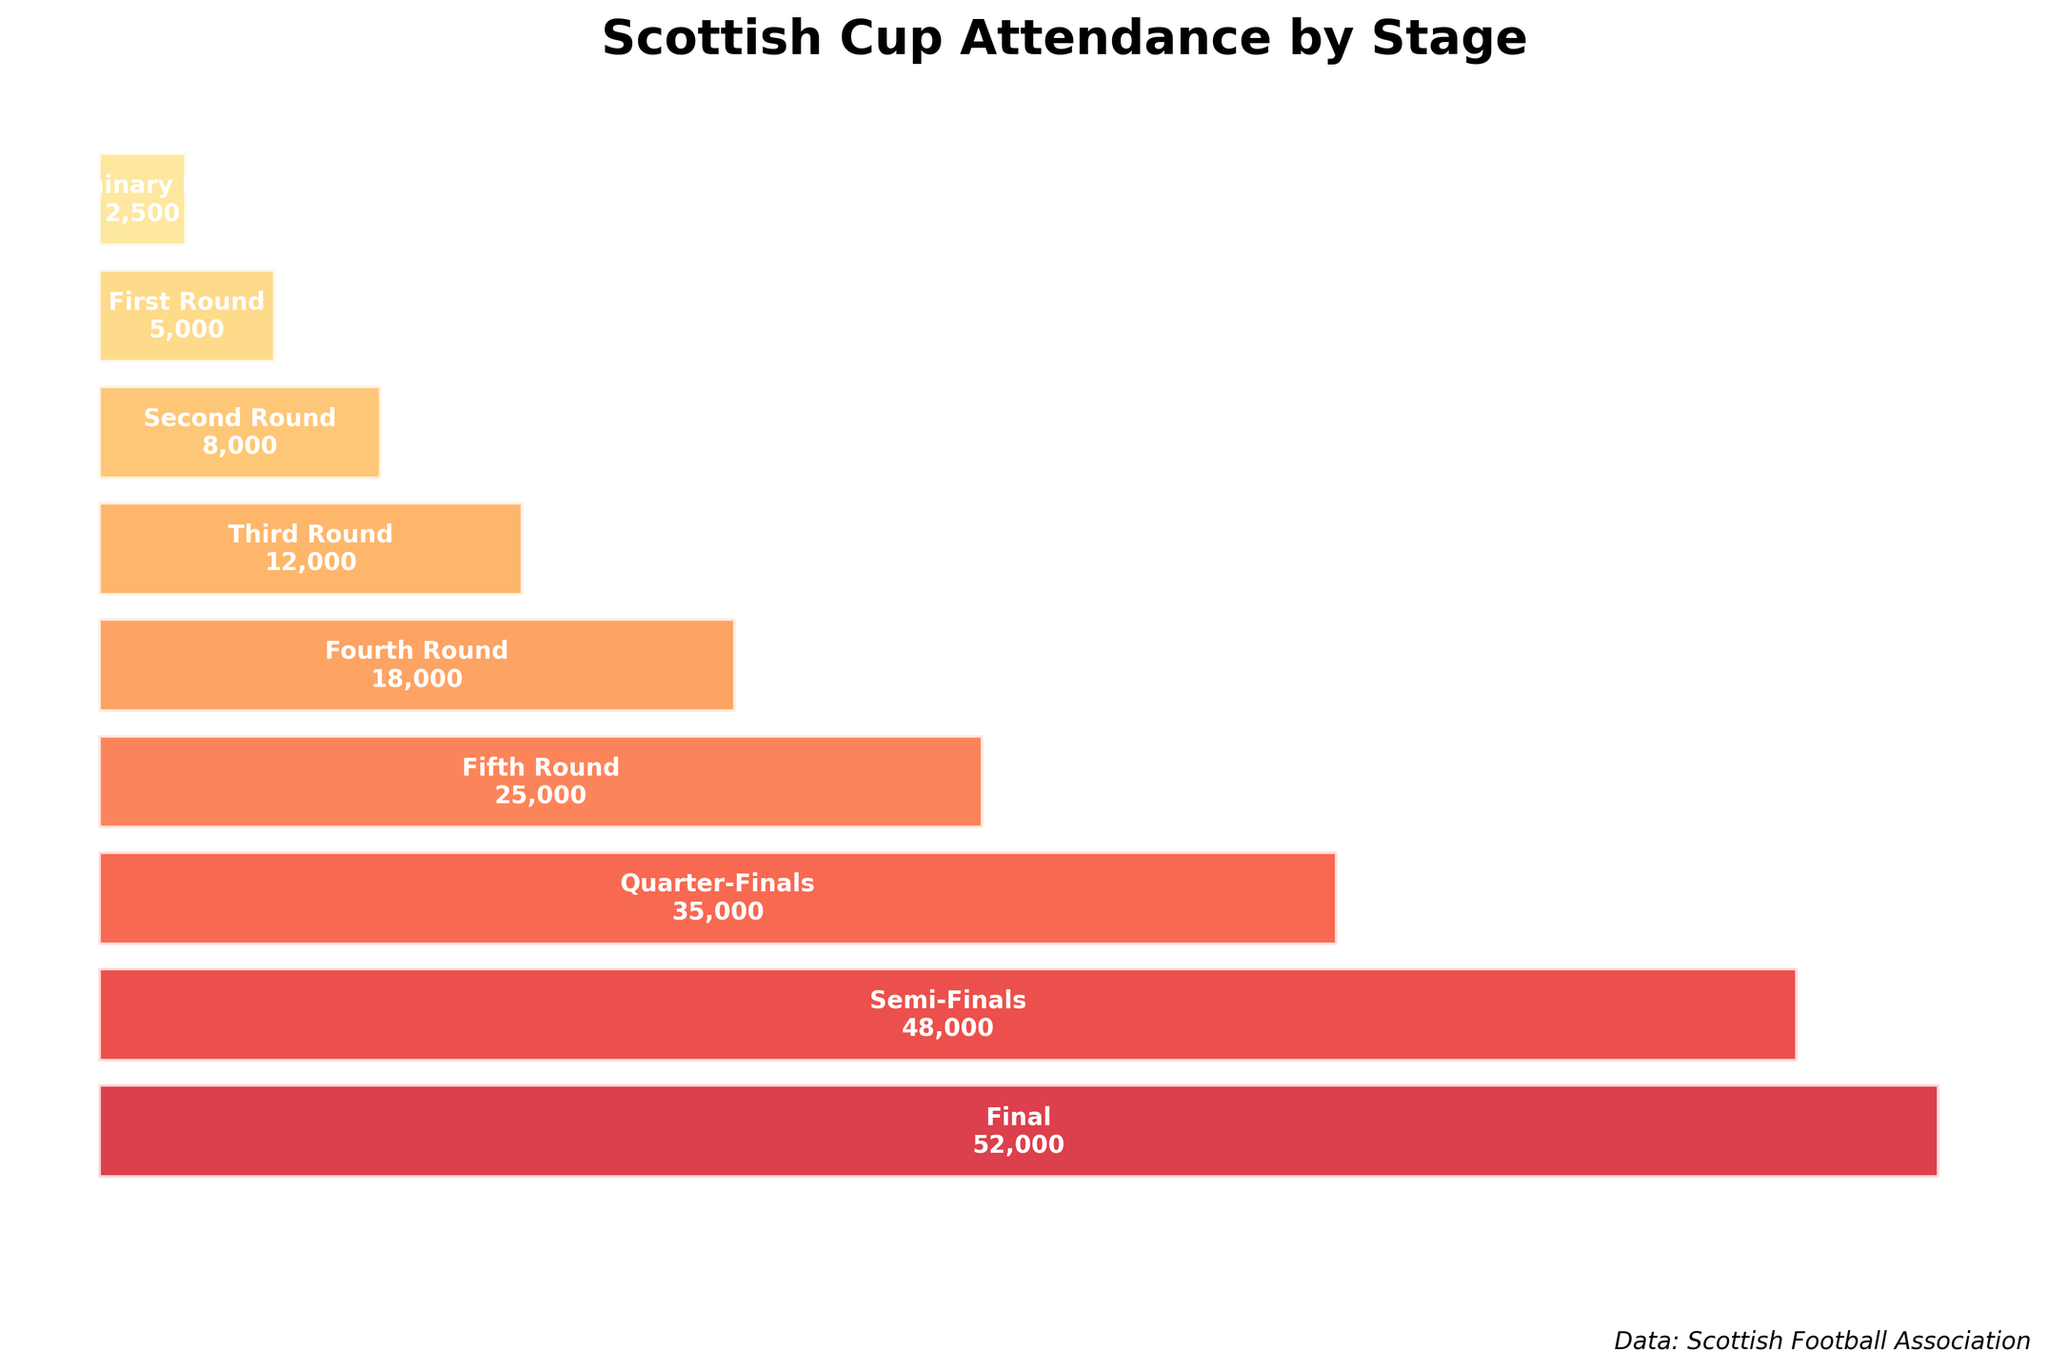What is the title of the figure? The title of the figure is located at the top center and it is usually in a larger and bold font. It reads "Scottish Cup Attendance by Stage".
Answer: Scottish Cup Attendance by Stage What is the attendance for the Prelimenary Round? The attendance for each stage is displayed within the bars in the figure. The Prelimenary Round shows an attendance figure of "2,500".
Answer: 2,500 Which stage shows the highest attendance figure? We look for the longest bar in the funnel chart which represents the highest attendance. The longest bar, and thus the highest attendance, is at the Final stage with "52,000".
Answer: Final What is the average attendance from the Preliminary Round to the Final? Sum the attendance figures for all stages (2,500 + 5,000 + 8,000 + 12,000 + 18,000 + 25,000 + 35,000 + 48,000 + 52,000) = 205,500 and divide by the number of stages, which is 9. The average is 205,500 / 9.
Answer: 22,833 How many more people attended the Final compared to the Quarter-Finals? Note the attendance figures for both the Final and Quarter-Finals. Subtract the Quarter-Finals attendance (35,000) from the Final attendance (52,000). So, 52,000 - 35,000 = 17,000.
Answer: 17,000 What is the total attendance from the Preliminary Round to the Fifth Round? Sum the attendance figures from the Preliminary Round to the Fifth Round (2,500 + 5,000 + 8,000 + 12,000 + 18,000 + 25,000) = 70,500.
Answer: 70,500 Are there more attendees in the Semi-Finals than in the Third Round? Compare the attendance figures for the Semi-Finals (48,000) and the Third Round (12,000). 48,000 > 12,000. So, yes, there are more attendees in the Semi-Finals.
Answer: Yes What percentage of the total attendance does the Final account for? First, calculate the total attendance (205,500). Next, divide the Final attendance (52,000) by the total attendance and multiply by 100 to get the percentage. (52,000 / 205,500) * 100 ≈ 25.3%.
Answer: 25.3% Does the attendance consistently increase from the Preliminary Round to the Final? Observe the bar lengths from Preliminary Round to the Final. Since each subsequent bar is longer than the previous one, the attendance consistently increases.
Answer: Yes 